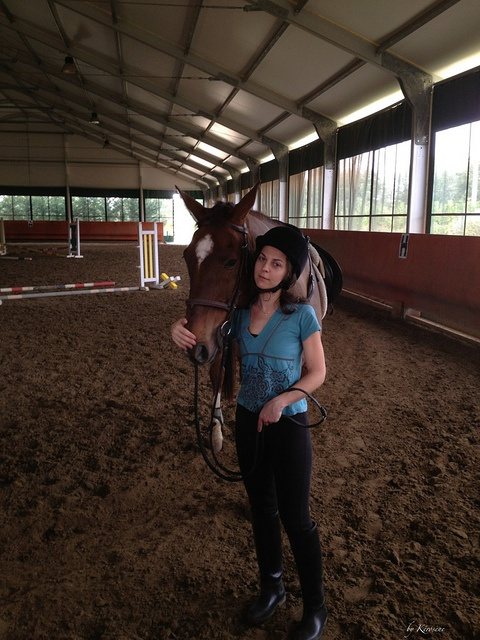Describe the objects in this image and their specific colors. I can see people in black, maroon, blue, and brown tones and horse in black, maroon, and gray tones in this image. 